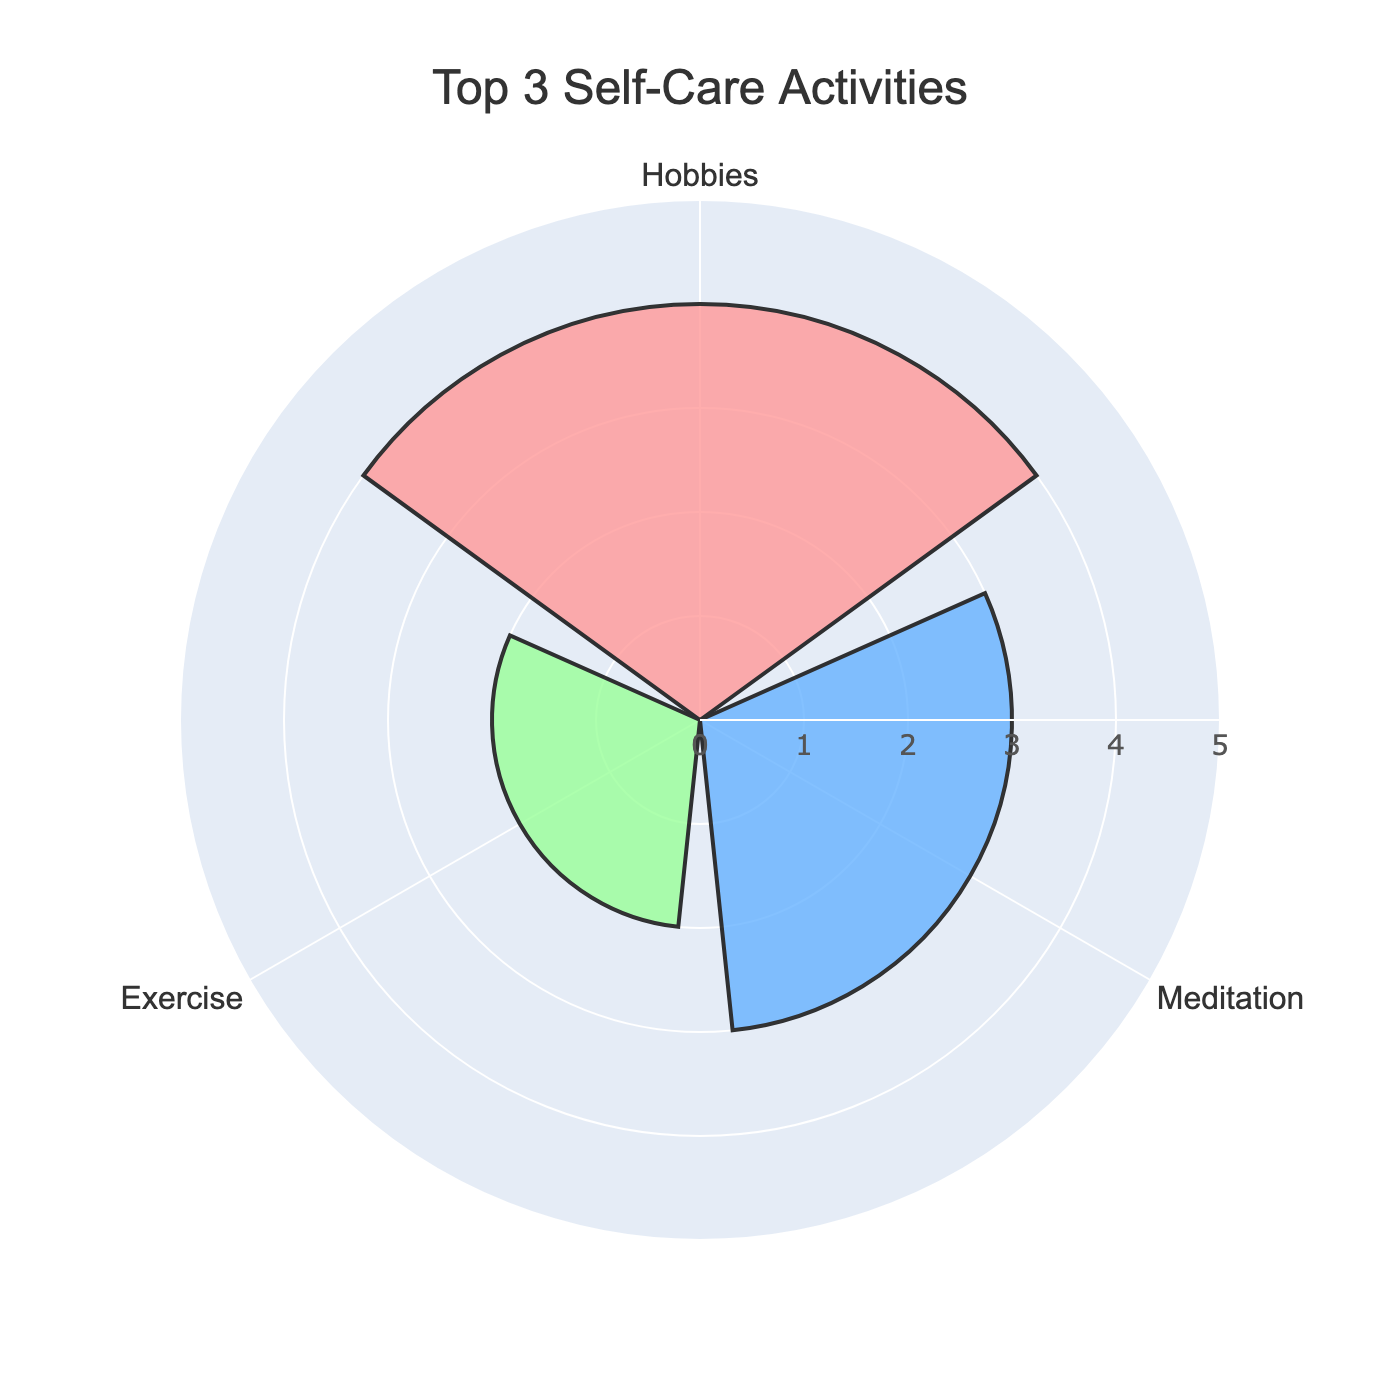What's the title of the figure? The title is located at the top center of the chart. It reads "Top 3 Self-Care Activities" in a large, bold font.
Answer: Top 3 Self-Care Activities How many activities are shown on the rose chart? By looking at the different sections or bars, we can count how many activities are represented.
Answer: 3 Which activity is engaged in the most frequently per week? The largest bar will represent the activity with the highest frequency. The hobby's bar is the largest, indicating it is the most frequent.
Answer: Hobbies What is the frequency of Meditation per week? The frequency of Meditation can be observed from the length of the corresponding bar. The Meditation bar extends to 3.
Answer: 3 What color is associated with the Exercise activity? To identify the color, look at the bar for Exercise. The color is a pinkish hue.
Answer: Pink How many more times is Hobbies engaged in compared to Socializing? We need to subtract the frequency of Socializing from the frequency of Hobbies (4 - 1).
Answer: 3 Which activity is engaged in the least frequently per week? The shortest bar represents the least frequently engaged activity. The Socializing bar is the shortest.
Answer: Socializing How many total times are the top 3 activities engaged in per week? Sum the frequencies of all the top 3 activities (2 for Exercise, 3 for Meditation, and 4 for Hobbies). 2 + 3 + 4 = 9
Answer: 9 Are the frequencies for Exercise and Meditation combined higher than Hobbies? Add the frequencies for Exercise and Meditation (2 + 3) and compare with the frequency for Hobbies (4). (2 + 3 = 5, which is greater than 4).
Answer: Yes What is the average weekly frequency of the top 3 self-care activities shown in the chart? Calculate the sum of frequencies (2 + 3 + 4 = 9), then divide by the number of activities (9 / 3).
Answer: 3 